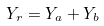<formula> <loc_0><loc_0><loc_500><loc_500>Y _ { r } = Y _ { a } + Y _ { b }</formula> 